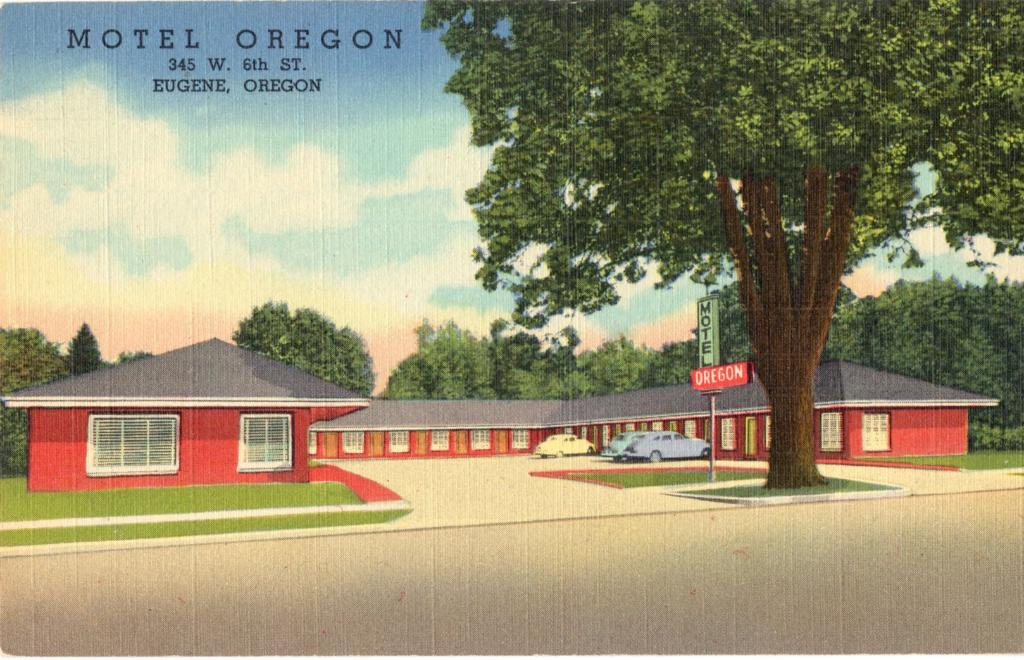What is the main subject of the photograph? The main subject of the photograph is a house. What can be seen in front of the house? There are vehicles, boards, and a tree in front of the house. How many trees are visible in the background of the image? There are many trees visible in the background of the image. What is visible in the sky in the background of the image? Clouds and the sky are visible in the background of the image. What type of thread is being used to hold the clouds in the image? There is no thread present in the image; the clouds are naturally occurring in the sky. What songs are being sung by the trees in the background of the image? Trees do not sing songs, so this question cannot be answered. 